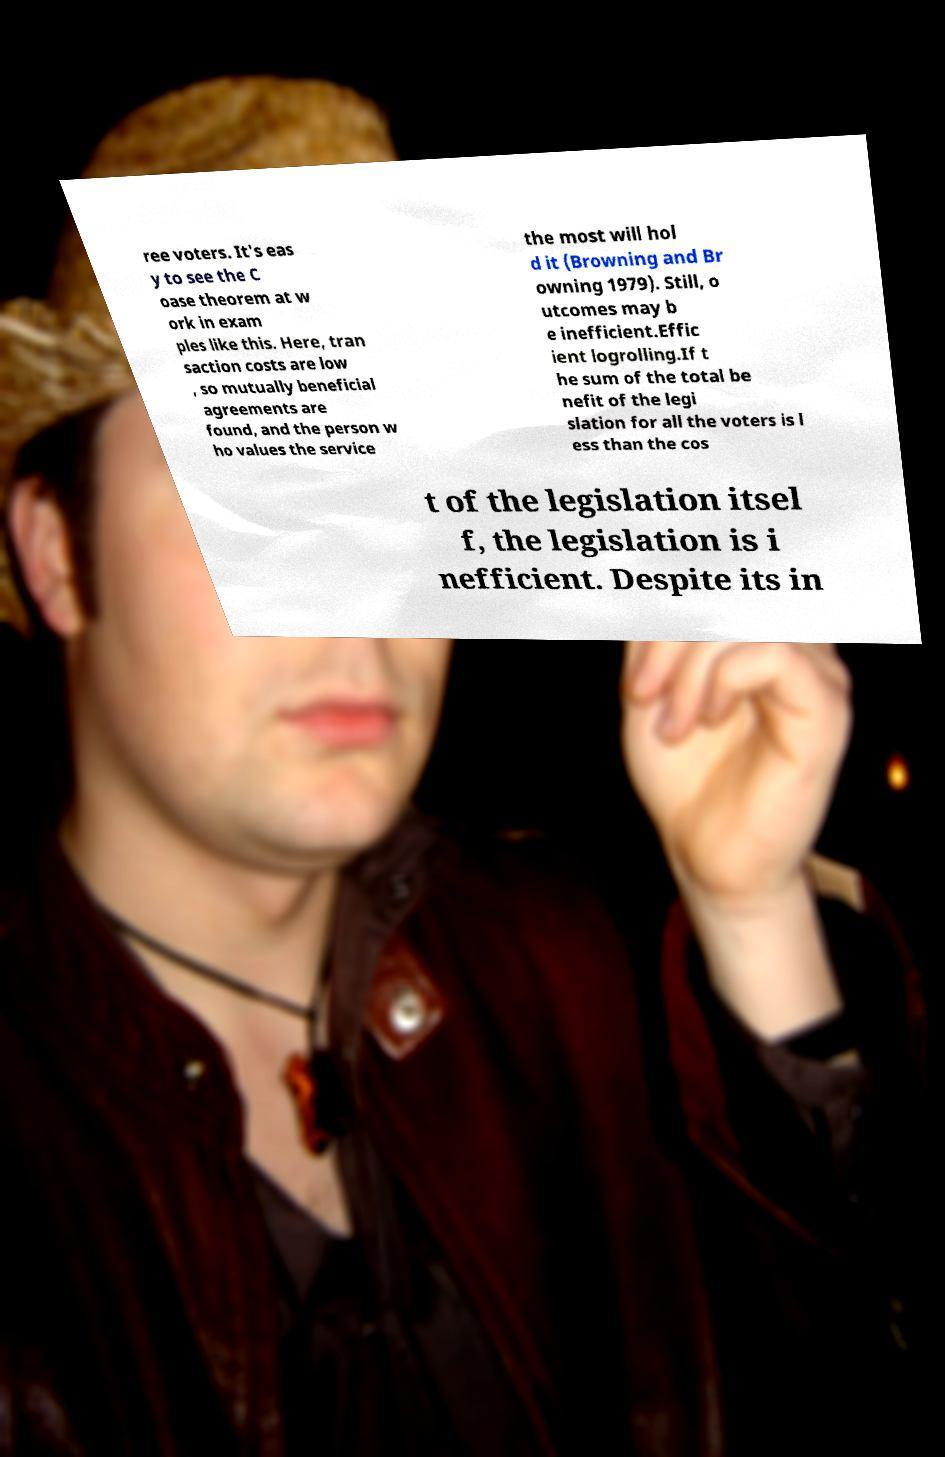For documentation purposes, I need the text within this image transcribed. Could you provide that? ree voters. It's eas y to see the C oase theorem at w ork in exam ples like this. Here, tran saction costs are low , so mutually beneficial agreements are found, and the person w ho values the service the most will hol d it (Browning and Br owning 1979). Still, o utcomes may b e inefficient.Effic ient logrolling.If t he sum of the total be nefit of the legi slation for all the voters is l ess than the cos t of the legislation itsel f, the legislation is i nefficient. Despite its in 